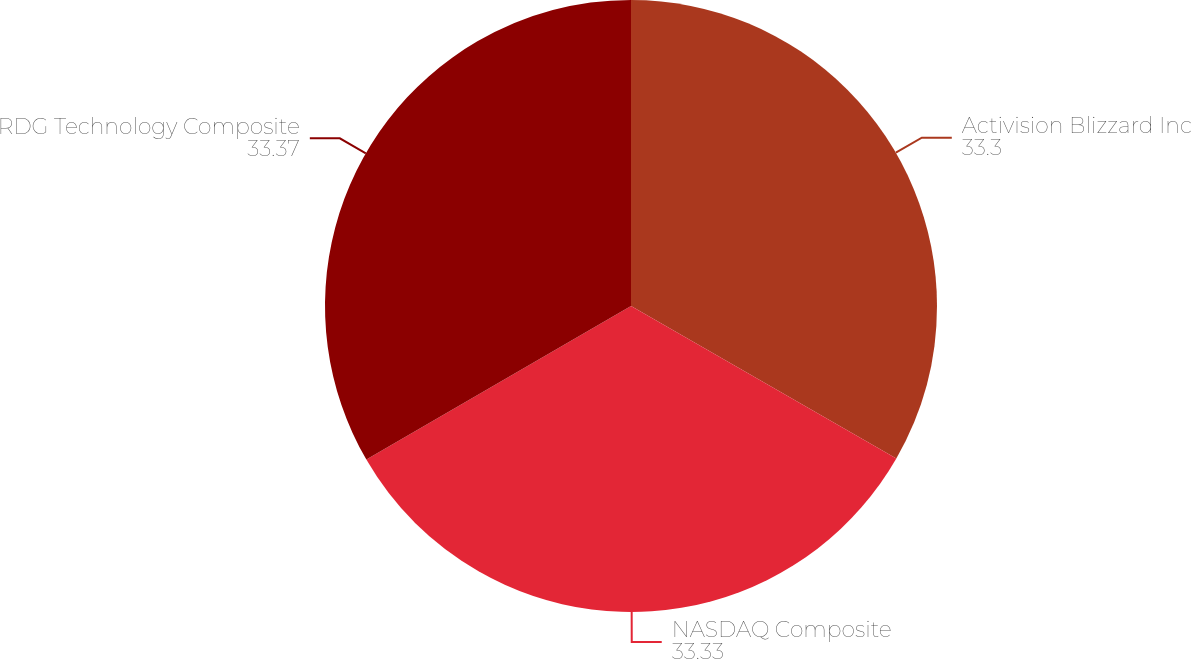<chart> <loc_0><loc_0><loc_500><loc_500><pie_chart><fcel>Activision Blizzard Inc<fcel>NASDAQ Composite<fcel>RDG Technology Composite<nl><fcel>33.3%<fcel>33.33%<fcel>33.37%<nl></chart> 